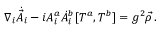Convert formula to latex. <formula><loc_0><loc_0><loc_500><loc_500>\nabla _ { i } \dot { \vec { A } } _ { i } - i A _ { i } ^ { a } \dot { A } _ { i } ^ { b } [ T ^ { a } , T ^ { b } ] = g ^ { 2 } \vec { \rho } \, .</formula> 